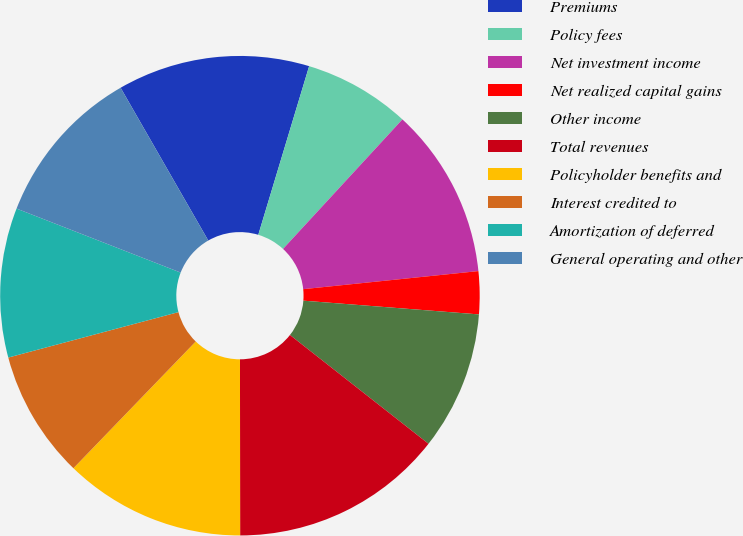Convert chart to OTSL. <chart><loc_0><loc_0><loc_500><loc_500><pie_chart><fcel>Premiums<fcel>Policy fees<fcel>Net investment income<fcel>Net realized capital gains<fcel>Other income<fcel>Total revenues<fcel>Policyholder benefits and<fcel>Interest credited to<fcel>Amortization of deferred<fcel>General operating and other<nl><fcel>12.95%<fcel>7.19%<fcel>11.51%<fcel>2.88%<fcel>9.35%<fcel>14.39%<fcel>12.23%<fcel>8.63%<fcel>10.07%<fcel>10.79%<nl></chart> 